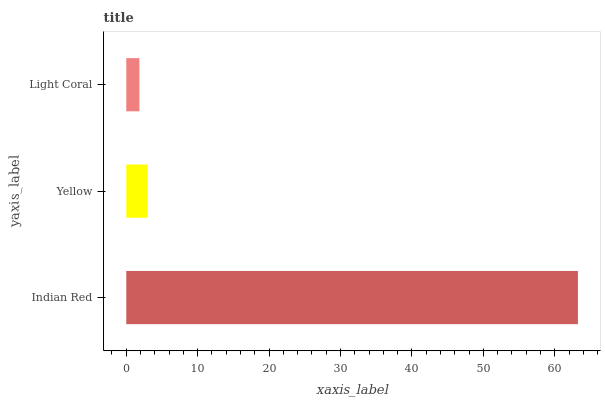Is Light Coral the minimum?
Answer yes or no. Yes. Is Indian Red the maximum?
Answer yes or no. Yes. Is Yellow the minimum?
Answer yes or no. No. Is Yellow the maximum?
Answer yes or no. No. Is Indian Red greater than Yellow?
Answer yes or no. Yes. Is Yellow less than Indian Red?
Answer yes or no. Yes. Is Yellow greater than Indian Red?
Answer yes or no. No. Is Indian Red less than Yellow?
Answer yes or no. No. Is Yellow the high median?
Answer yes or no. Yes. Is Yellow the low median?
Answer yes or no. Yes. Is Light Coral the high median?
Answer yes or no. No. Is Indian Red the low median?
Answer yes or no. No. 